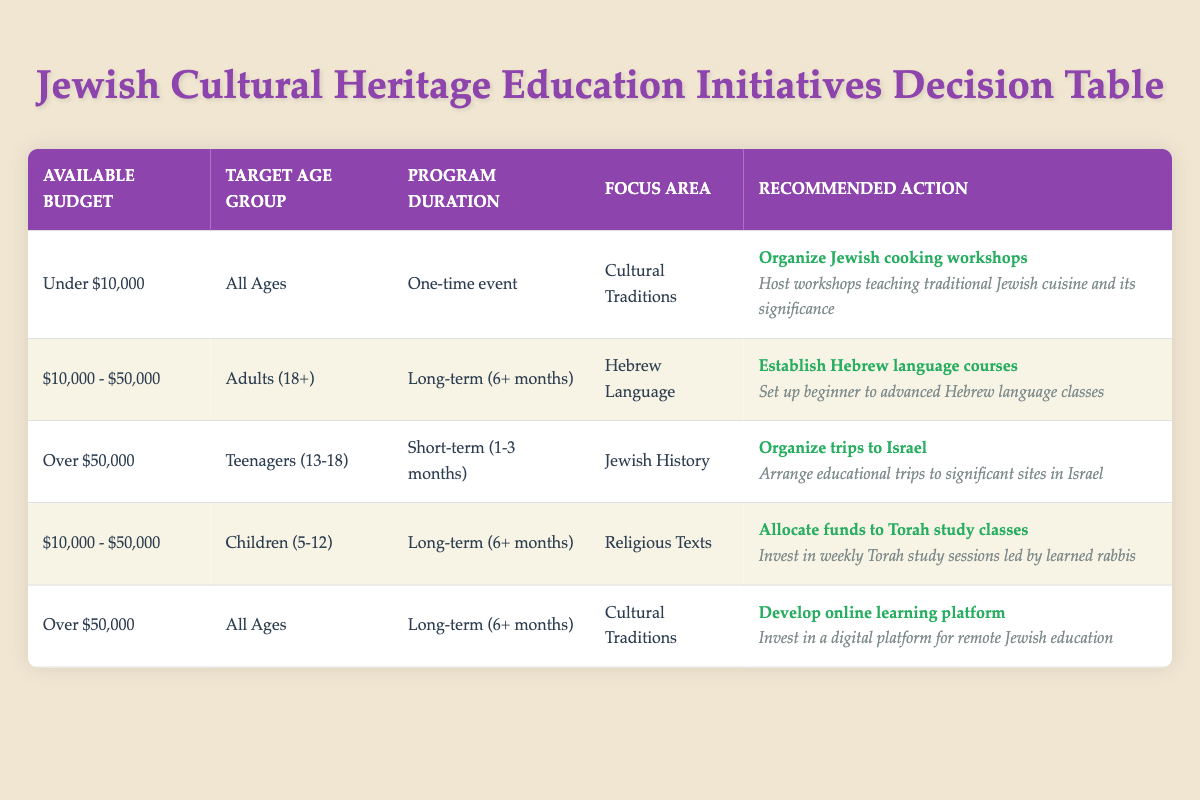What is the action recommended for a program with an available budget of over $50,000, targeting teenagers? The table indicates that for an available budget of over $50,000, targeting teenagers, the action is to organize trips to Israel. This can be found by locating the row that lists "Over $50,000" under the "Available Budget" column and "Teenagers (13-18)" under the "Target Age Group" column, where the recommended action is specified.
Answer: Organize trips to Israel What focus area is chosen for long-term programs aimed at adults with a budget of $10,000 to $50,000? The table shows that for the budget range of $10,000 to $50,000 and targeting adults (18+) for a long-term (6+ months) program, the focus area is Hebrew Language. This is identified in the corresponding row under the "Focus Area" column.
Answer: Hebrew Language Are there any programs aimed at all ages that require a budget under $10,000? Yes, the table confirms that there is a program aimed at all ages that requires a budget under $10,000: organizing Jewish cooking workshops. This is validated by checking the conditions in the respective row.
Answer: Yes What is the action recommended for children (5-12) with a budget of $10,000 - $50,000 for a long-term program? The table states that for children (5-12) with a budget between $10,000 and $50,000 for a long-term (6+ months) program, the action is to allocate funds to Torah study classes. This is found by locating the relevant row where all conditions match.
Answer: Allocate funds to Torah study classes How many programs in the table focus on Cultural Traditions for budgets over $50,000? The table shows one program that focuses on Cultural Traditions for budgets over $50,000, which is the development of an online learning platform. By inspecting the relevant row, it's clear that only this action aligns with both conditions.
Answer: 1 